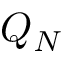Convert formula to latex. <formula><loc_0><loc_0><loc_500><loc_500>Q _ { N }</formula> 